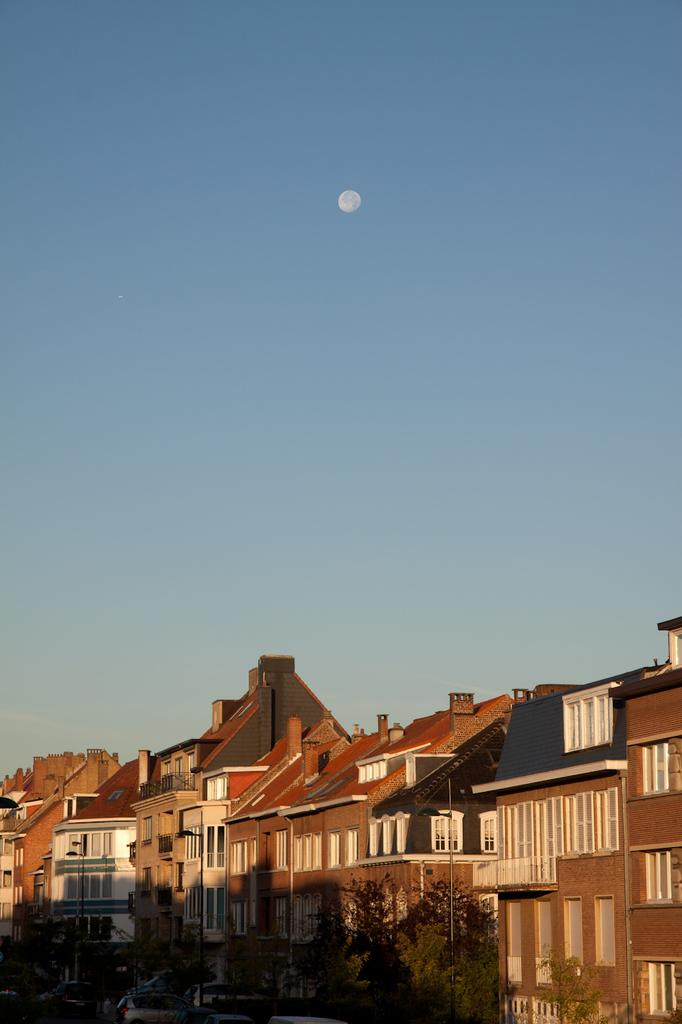What type of structures are visible in the image? There are buildings with windows in the image. Where are the buildings located? The buildings are over a place, suggesting they are elevated or on a higher ground. What can be seen in the front of the image? There are plants and trees in the front of the image. What is the condition of the plants and trees? The plants and trees are covered, possibly indicating that they are protected or in a specific environment. What celestial body is visible in the sky? The moon is visible in the sky. What type of punishment is being administered to the plants in the image? There is no indication of punishment being administered to the plants in the image. The plants are simply covered, which could be for various reasons such as protection or maintenance. 